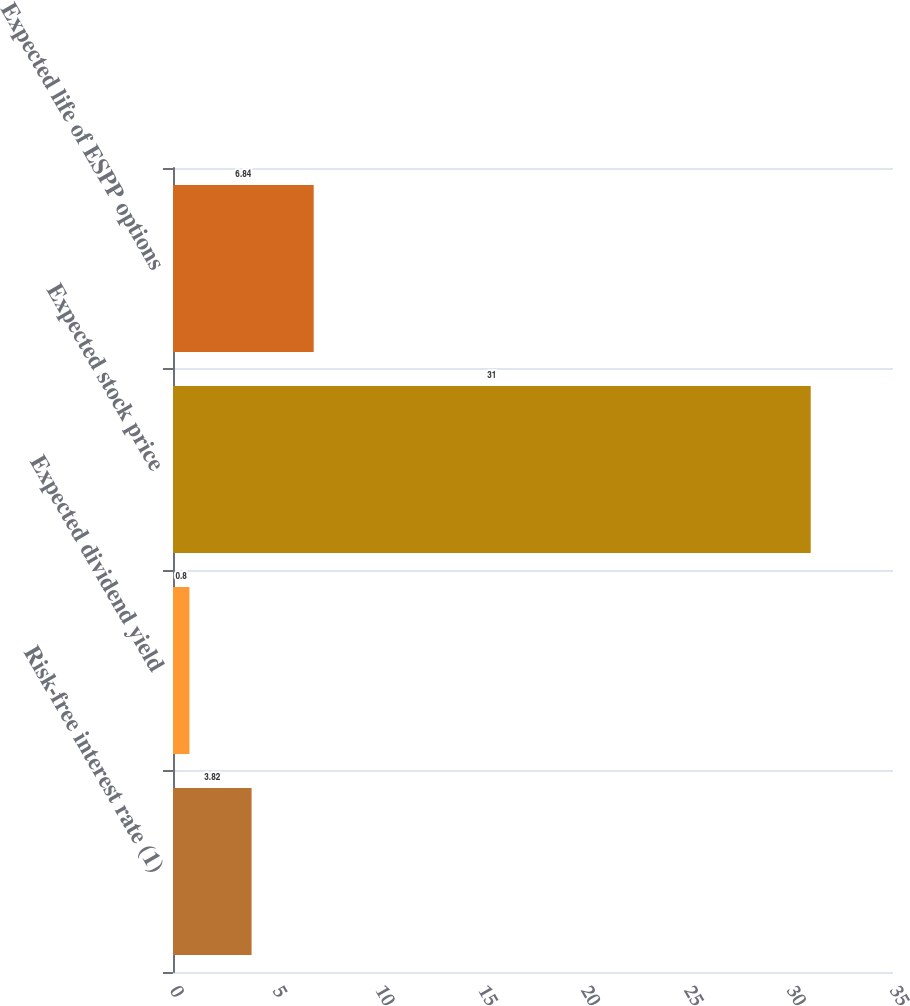Convert chart to OTSL. <chart><loc_0><loc_0><loc_500><loc_500><bar_chart><fcel>Risk-free interest rate (1)<fcel>Expected dividend yield<fcel>Expected stock price<fcel>Expected life of ESPP options<nl><fcel>3.82<fcel>0.8<fcel>31<fcel>6.84<nl></chart> 